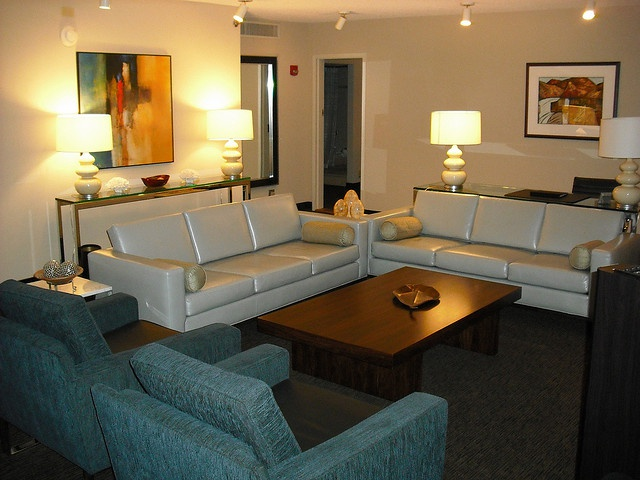Describe the objects in this image and their specific colors. I can see chair in gray, teal, black, and darkblue tones, couch in gray tones, chair in gray, black, and purple tones, couch in gray tones, and tv in gray, black, maroon, and darkgray tones in this image. 